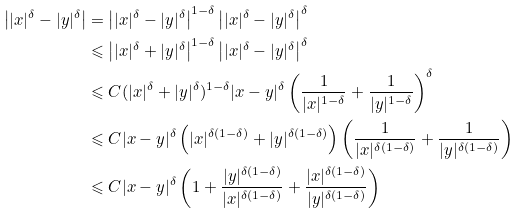Convert formula to latex. <formula><loc_0><loc_0><loc_500><loc_500>\left | | { x } | ^ { \delta } - | { y } | ^ { \delta } \right | & = \left | | { x } | ^ { \delta } - | { y } | ^ { \delta } \right | ^ { 1 - \delta } \left | | { x } | ^ { \delta } - | { y } | ^ { \delta } \right | ^ { \delta } \\ & \leqslant \left | | { x } | ^ { \delta } + | { y } | ^ { \delta } \right | ^ { 1 - \delta } \left | | { x } | ^ { \delta } - | { y } | ^ { \delta } \right | ^ { \delta } \\ & \leqslant C ( | { x } | ^ { \delta } + | { y } | ^ { \delta } ) ^ { 1 - \delta } | { x - y } | ^ { \delta } \left ( \frac { 1 } { | { x } | ^ { 1 - \delta } } + \frac { 1 } { | { y } | ^ { 1 - \delta } } \right ) ^ { \delta } \\ & \leqslant C | { x - y } | ^ { \delta } \left ( | { x } | ^ { \delta ( 1 - \delta ) } + | { y } | ^ { \delta ( 1 - \delta ) } \right ) \left ( \frac { 1 } { | { x } | ^ { \delta ( 1 - \delta ) } } + \frac { 1 } { | { y } | ^ { \delta ( 1 - \delta ) } } \right ) \\ & \leqslant C | { x - y } | ^ { \delta } \left ( 1 + \frac { | { y } | ^ { \delta ( 1 - \delta ) } } { | { x } | ^ { \delta ( 1 - \delta ) } } + \frac { | { x } | ^ { \delta ( 1 - \delta ) } } { | { y } | ^ { \delta ( 1 - \delta ) } } \right )</formula> 